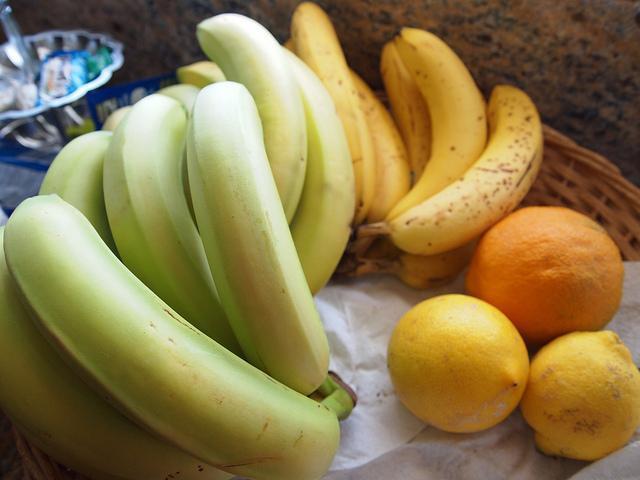How many lemons are there?
Give a very brief answer. 2. How many different types of fruit are there?
Give a very brief answer. 2. How many oranges are there?
Give a very brief answer. 3. How many bananas are there?
Give a very brief answer. 7. 